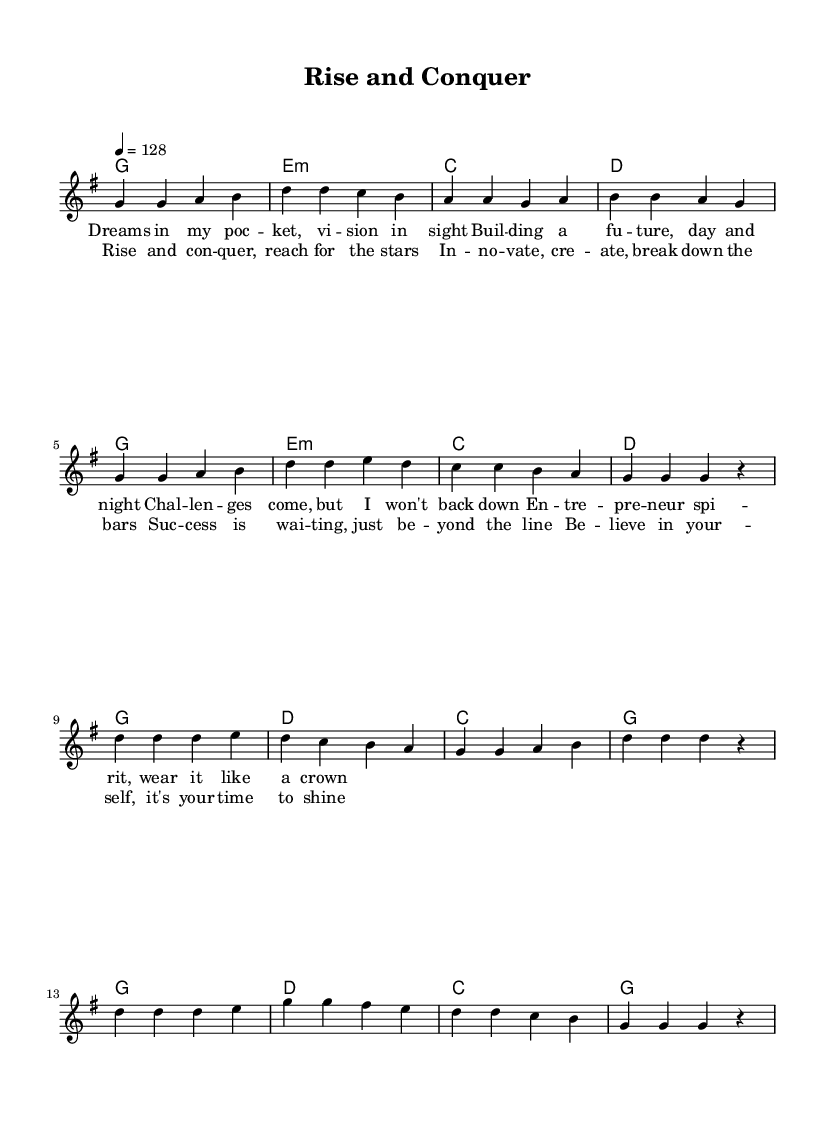What is the key signature of this music? The key signature is G major, which has one sharp (F#). This can be identified from the key signature indicated at the beginning of the sheet music.
Answer: G major What is the time signature of this music? The time signature is 4/4, meaning there are four beats per measure. This is shown at the beginning of the sheet music where the time signature is written.
Answer: 4/4 What is the tempo indicated in the music? The tempo is marked as quarter note equals 128 beats per minute. This is written in the tempo marking at the beginning of the sheet music.
Answer: 128 How many measures are in the verse section? The verse section consists of 8 measures, noted by counting the measure bars at the beginning of each section in the music.
Answer: 8 Which section of the song has the lyrics "Rise and conquer, reach for the stars"? This line is part of the chorus, which is indicated in the music structure. The lyrics are specifically under the labeled chorus section.
Answer: Chorus What type of chord progression is used in the verse? The chord progression in the verse is a simple diatonic progression with G, E minor, C, and D chords, all belonging to G major. This can be determined by examining the chords listed under the verse section.
Answer: Diatonic progression How many times is the chorus repeated in the music? The chorus is repeated two times, as shown by the layout of the lyrics and corresponding chords, indicating the repetition after the first performance of the chorus.
Answer: 2 